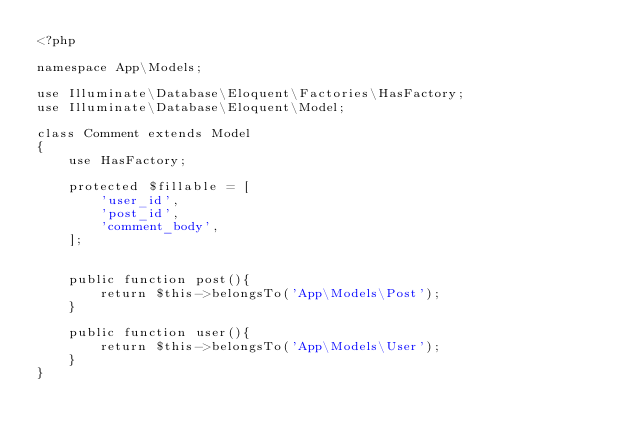<code> <loc_0><loc_0><loc_500><loc_500><_PHP_><?php

namespace App\Models;

use Illuminate\Database\Eloquent\Factories\HasFactory;
use Illuminate\Database\Eloquent\Model;

class Comment extends Model
{
    use HasFactory;

    protected $fillable = [
        'user_id',
        'post_id',
        'comment_body',
    ];


    public function post(){
        return $this->belongsTo('App\Models\Post');
    }

    public function user(){
        return $this->belongsTo('App\Models\User');
    }
}
</code> 